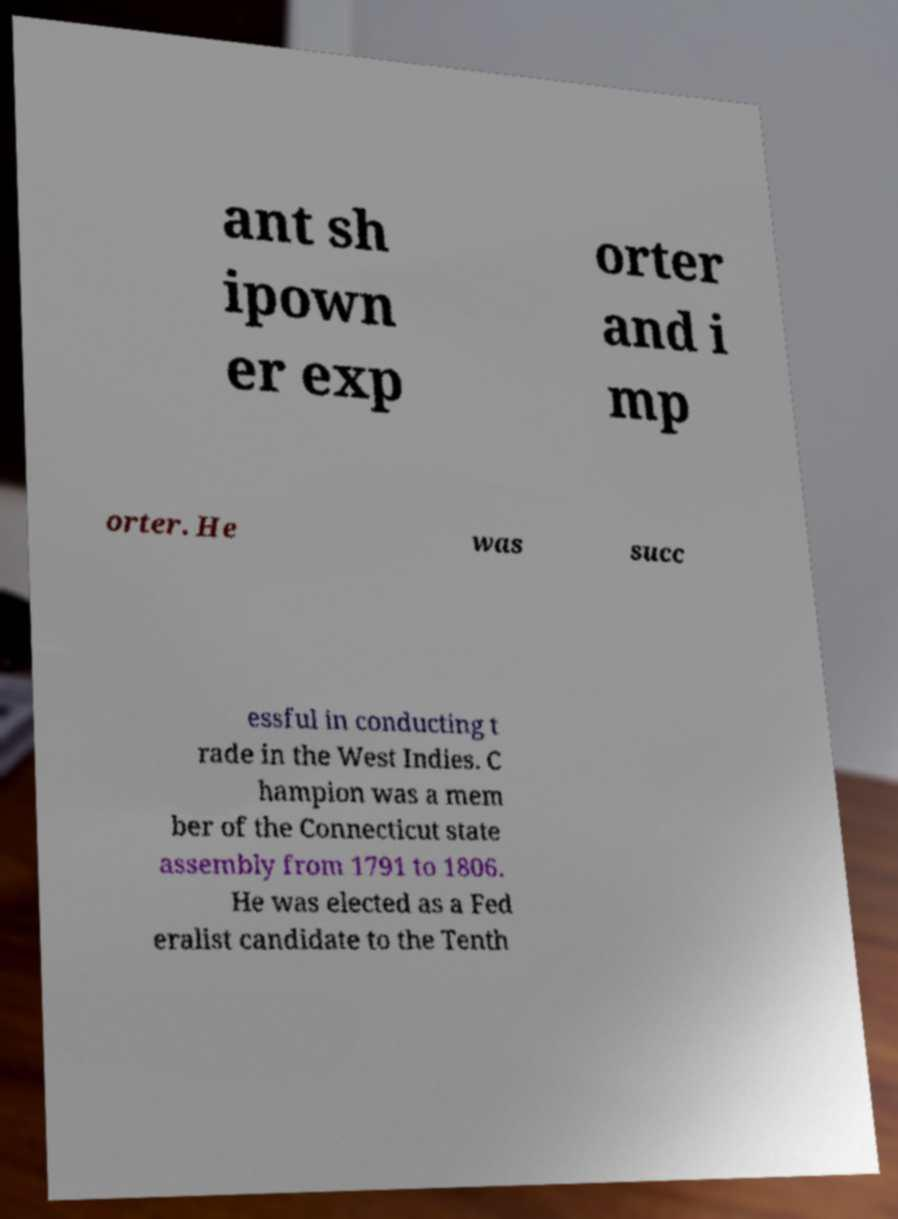There's text embedded in this image that I need extracted. Can you transcribe it verbatim? ant sh ipown er exp orter and i mp orter. He was succ essful in conducting t rade in the West Indies. C hampion was a mem ber of the Connecticut state assembly from 1791 to 1806. He was elected as a Fed eralist candidate to the Tenth 